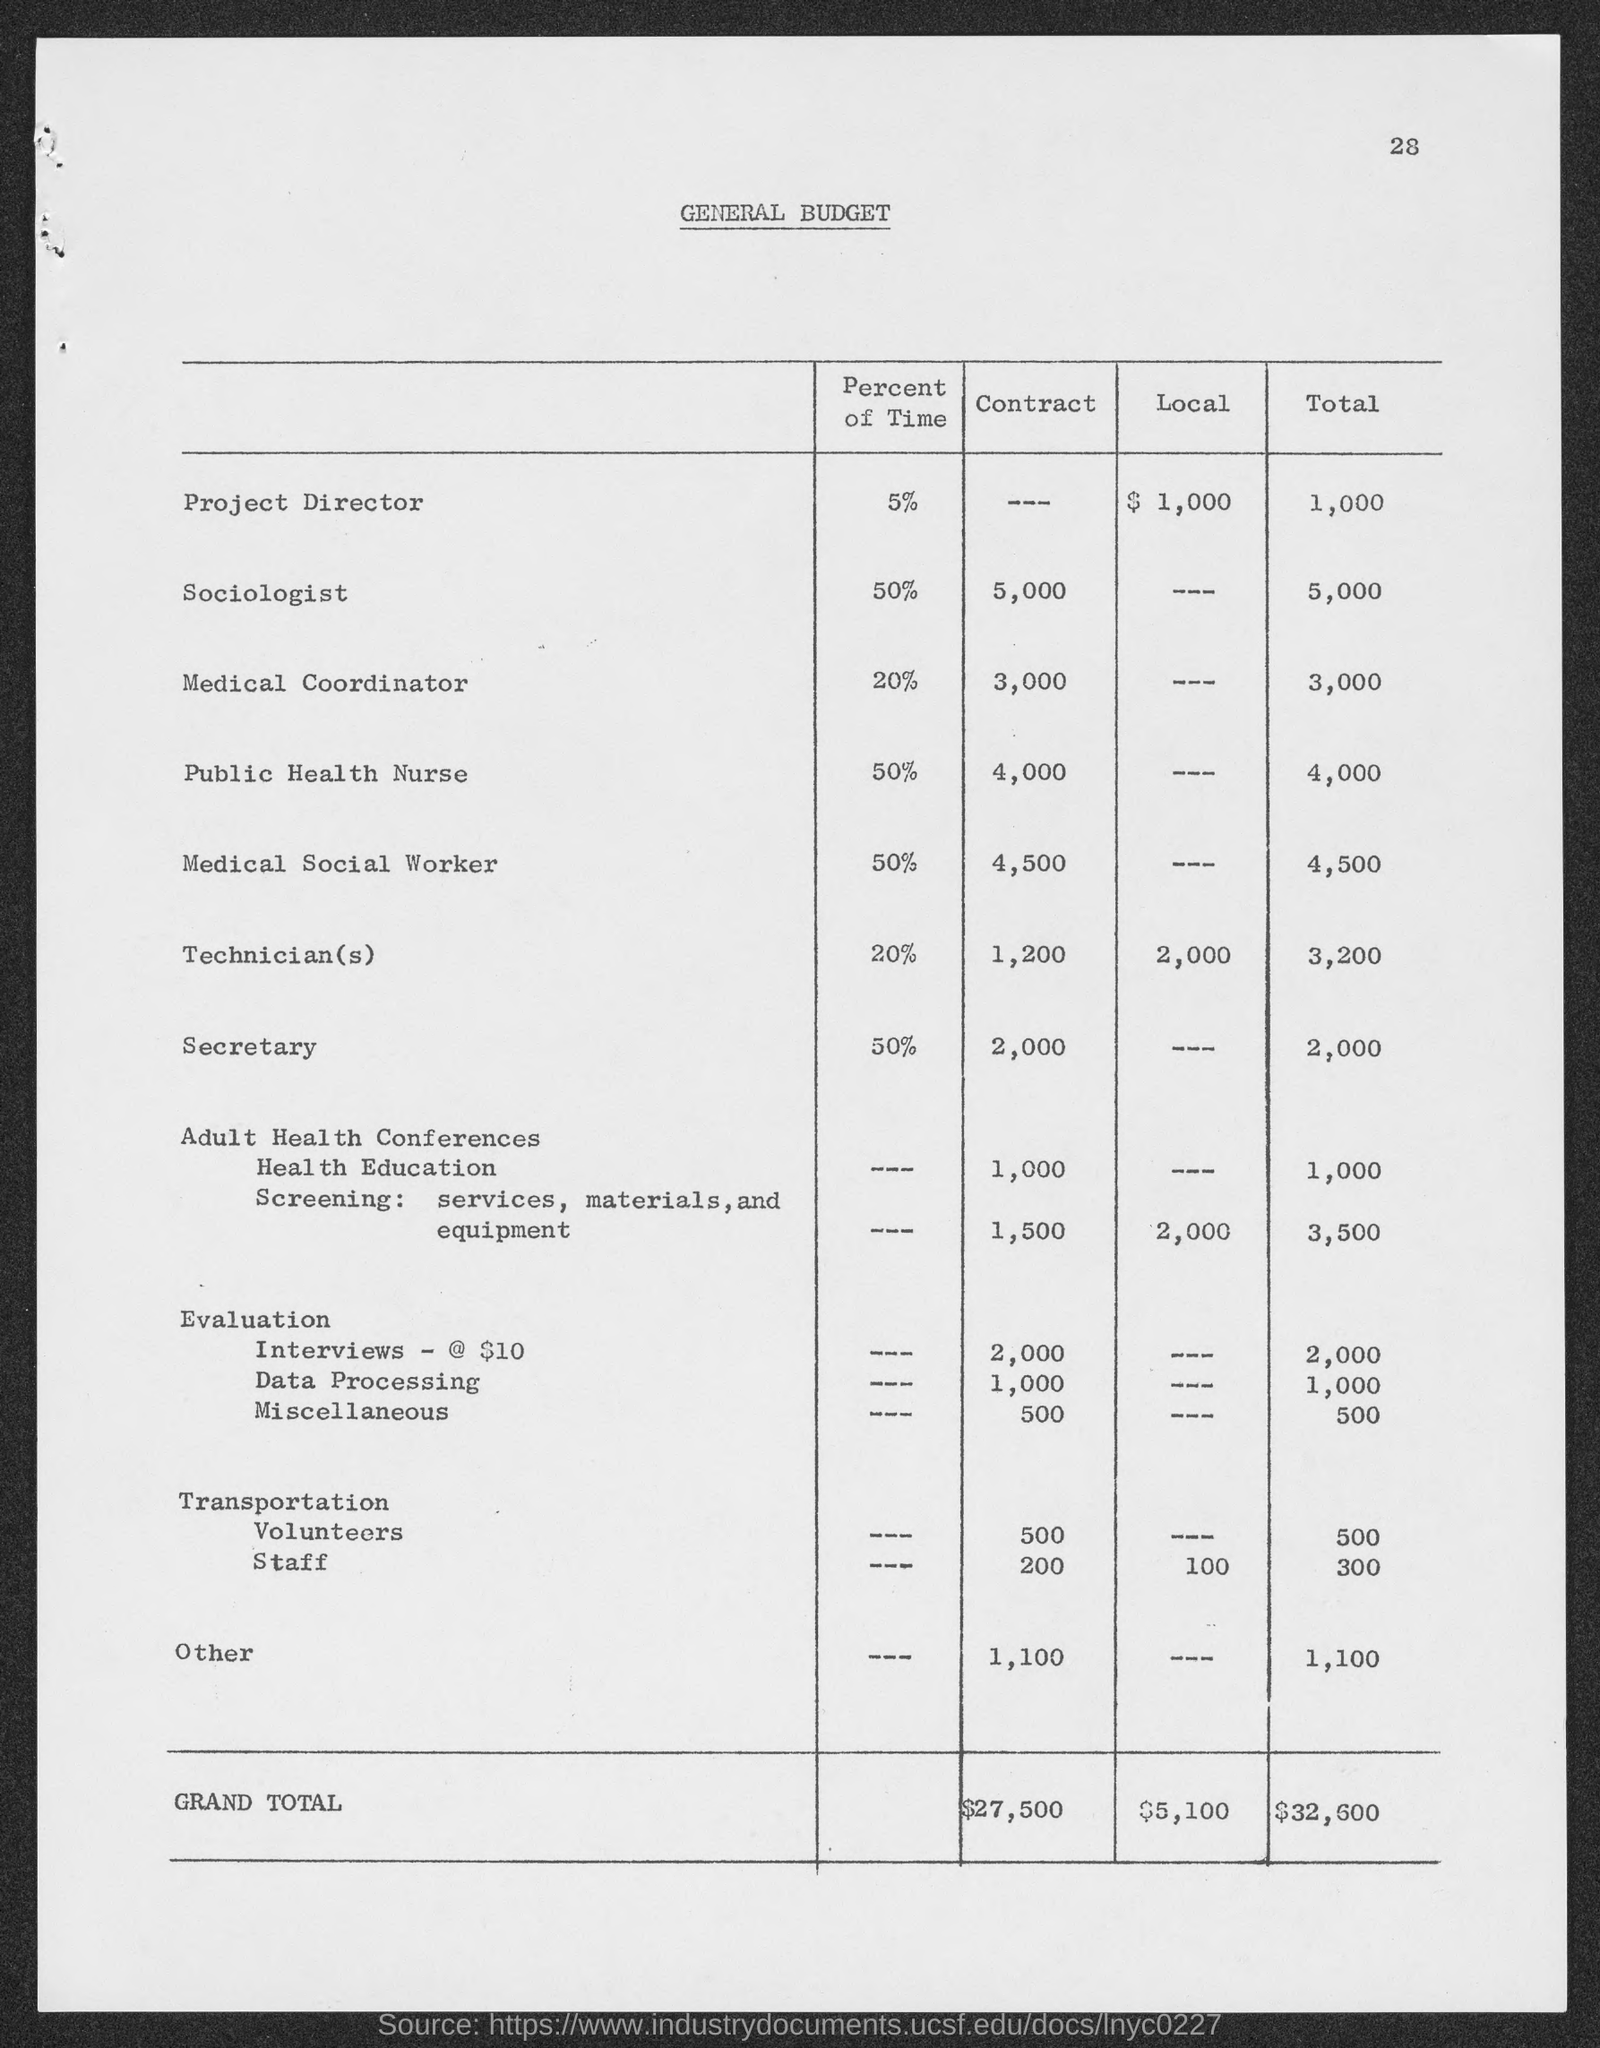Highlight a few significant elements in this photo. The general budget total for a sociologist is approximately $5,000. The total budget for a public health nurse is $4,000. The general budget total for the Secretary is $2,000. The total budget for Technician(s) is $3,200. At the top of the page, the page number is 28. 